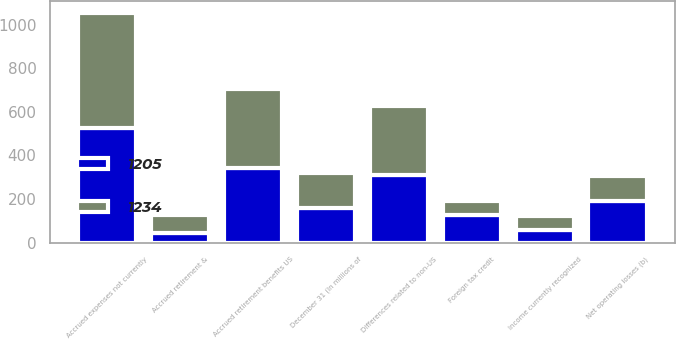<chart> <loc_0><loc_0><loc_500><loc_500><stacked_bar_chart><ecel><fcel>December 31 (In millions of<fcel>Accrued expenses not currently<fcel>Differences related to non-US<fcel>Accrued retirement &<fcel>Accrued retirement benefits US<fcel>Net operating losses (b)<fcel>Income currently recognized<fcel>Foreign tax credit<nl><fcel>1205<fcel>159.5<fcel>524<fcel>310<fcel>45<fcel>344<fcel>190<fcel>57<fcel>129<nl><fcel>1234<fcel>159.5<fcel>530<fcel>316<fcel>80<fcel>359<fcel>115<fcel>67<fcel>60<nl></chart> 